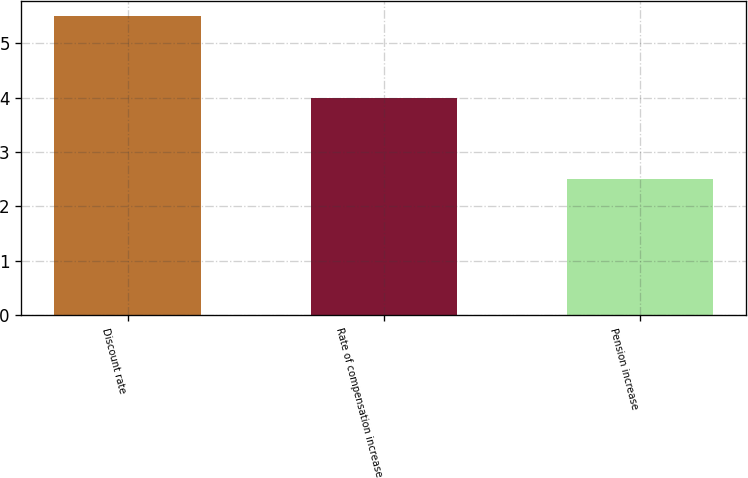Convert chart to OTSL. <chart><loc_0><loc_0><loc_500><loc_500><bar_chart><fcel>Discount rate<fcel>Rate of compensation increase<fcel>Pension increase<nl><fcel>5.5<fcel>4<fcel>2.5<nl></chart> 